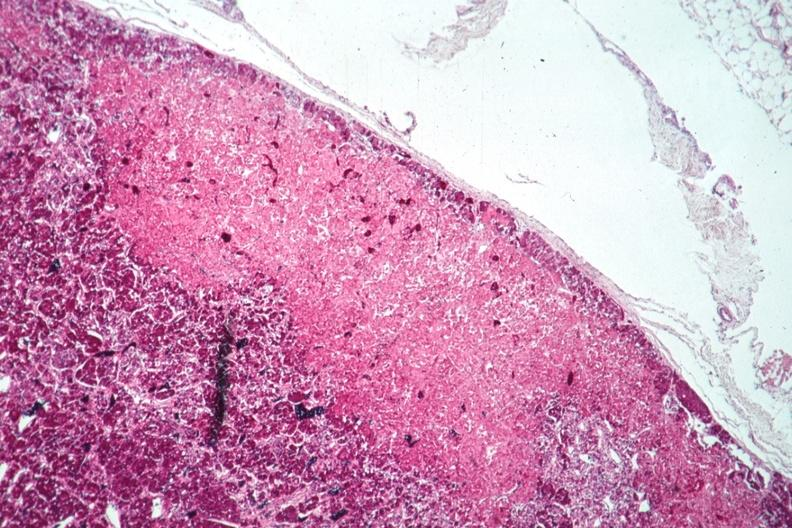what is present?
Answer the question using a single word or phrase. Endocrine 